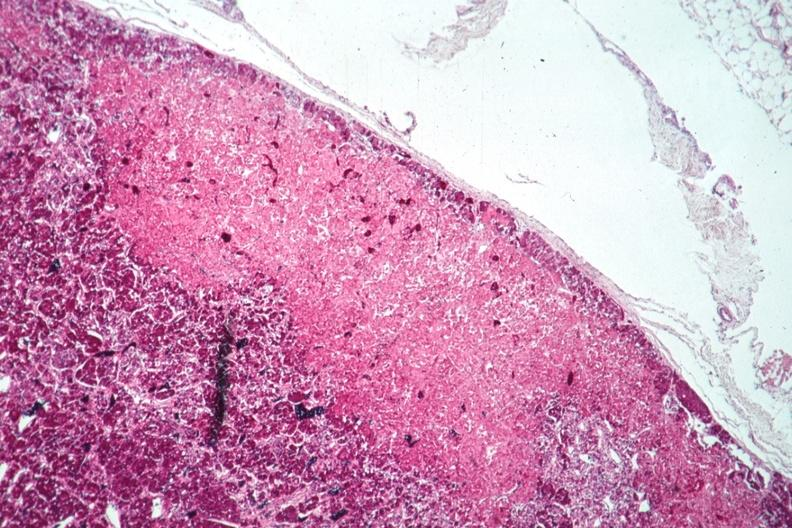what is present?
Answer the question using a single word or phrase. Endocrine 